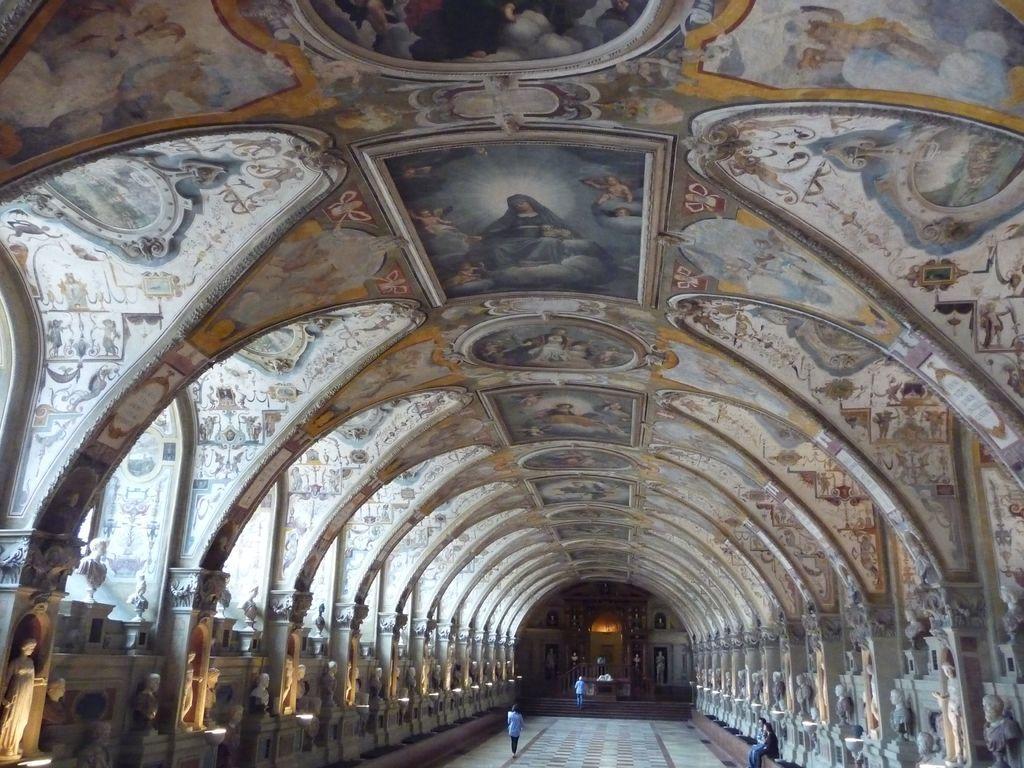In one or two sentences, can you explain what this image depicts? The picture is taken inside a big hall. On both sides there are pillars, statues. On the roof there are many designs. There are picture at the top. In the hall few people are there. In the background there are statue, arch. This is the floor. 